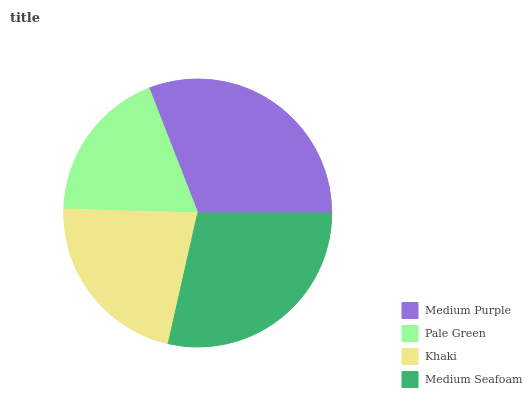Is Pale Green the minimum?
Answer yes or no. Yes. Is Medium Purple the maximum?
Answer yes or no. Yes. Is Khaki the minimum?
Answer yes or no. No. Is Khaki the maximum?
Answer yes or no. No. Is Khaki greater than Pale Green?
Answer yes or no. Yes. Is Pale Green less than Khaki?
Answer yes or no. Yes. Is Pale Green greater than Khaki?
Answer yes or no. No. Is Khaki less than Pale Green?
Answer yes or no. No. Is Medium Seafoam the high median?
Answer yes or no. Yes. Is Khaki the low median?
Answer yes or no. Yes. Is Khaki the high median?
Answer yes or no. No. Is Medium Seafoam the low median?
Answer yes or no. No. 